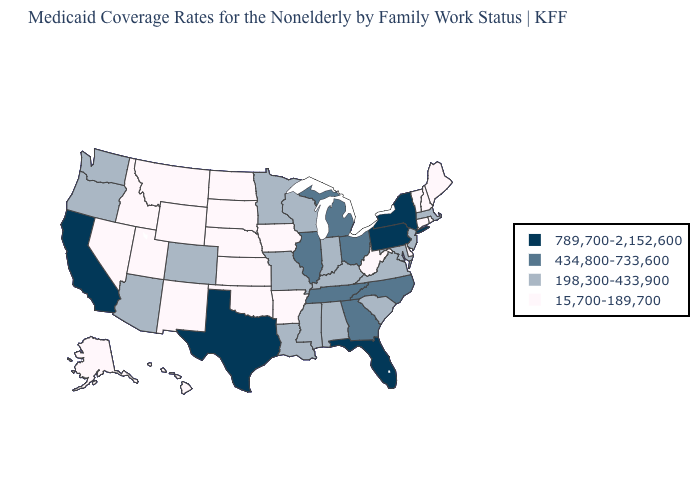What is the value of Missouri?
Answer briefly. 198,300-433,900. Name the states that have a value in the range 15,700-189,700?
Give a very brief answer. Alaska, Arkansas, Connecticut, Delaware, Hawaii, Idaho, Iowa, Kansas, Maine, Montana, Nebraska, Nevada, New Hampshire, New Mexico, North Dakota, Oklahoma, Rhode Island, South Dakota, Utah, Vermont, West Virginia, Wyoming. What is the value of Kentucky?
Answer briefly. 198,300-433,900. Among the states that border Missouri , does Arkansas have the lowest value?
Concise answer only. Yes. Name the states that have a value in the range 198,300-433,900?
Quick response, please. Alabama, Arizona, Colorado, Indiana, Kentucky, Louisiana, Maryland, Massachusetts, Minnesota, Mississippi, Missouri, New Jersey, Oregon, South Carolina, Virginia, Washington, Wisconsin. Does the map have missing data?
Quick response, please. No. Which states have the lowest value in the USA?
Answer briefly. Alaska, Arkansas, Connecticut, Delaware, Hawaii, Idaho, Iowa, Kansas, Maine, Montana, Nebraska, Nevada, New Hampshire, New Mexico, North Dakota, Oklahoma, Rhode Island, South Dakota, Utah, Vermont, West Virginia, Wyoming. What is the lowest value in the South?
Answer briefly. 15,700-189,700. Name the states that have a value in the range 434,800-733,600?
Concise answer only. Georgia, Illinois, Michigan, North Carolina, Ohio, Tennessee. Name the states that have a value in the range 789,700-2,152,600?
Keep it brief. California, Florida, New York, Pennsylvania, Texas. What is the highest value in the West ?
Answer briefly. 789,700-2,152,600. Name the states that have a value in the range 198,300-433,900?
Short answer required. Alabama, Arizona, Colorado, Indiana, Kentucky, Louisiana, Maryland, Massachusetts, Minnesota, Mississippi, Missouri, New Jersey, Oregon, South Carolina, Virginia, Washington, Wisconsin. What is the value of Wisconsin?
Quick response, please. 198,300-433,900. What is the value of Michigan?
Concise answer only. 434,800-733,600. How many symbols are there in the legend?
Concise answer only. 4. 